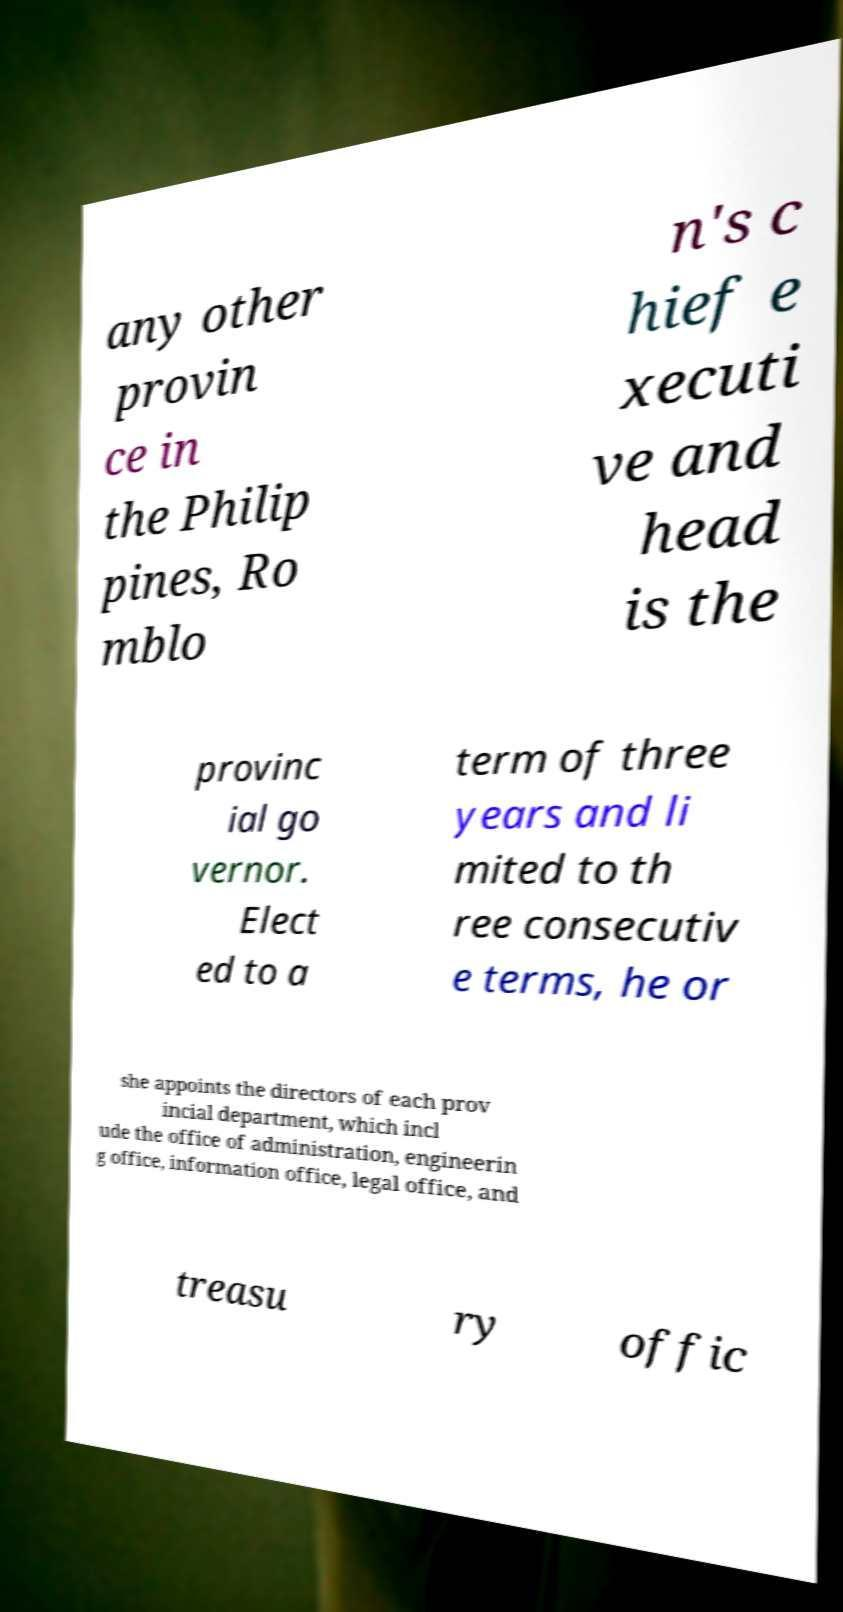Can you accurately transcribe the text from the provided image for me? any other provin ce in the Philip pines, Ro mblo n's c hief e xecuti ve and head is the provinc ial go vernor. Elect ed to a term of three years and li mited to th ree consecutiv e terms, he or she appoints the directors of each prov incial department, which incl ude the office of administration, engineerin g office, information office, legal office, and treasu ry offic 